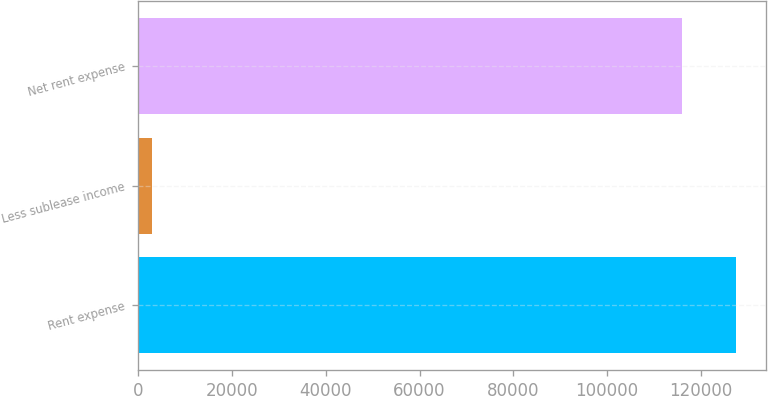Convert chart. <chart><loc_0><loc_0><loc_500><loc_500><bar_chart><fcel>Rent expense<fcel>Less sublease income<fcel>Net rent expense<nl><fcel>127511<fcel>3057<fcel>115919<nl></chart> 